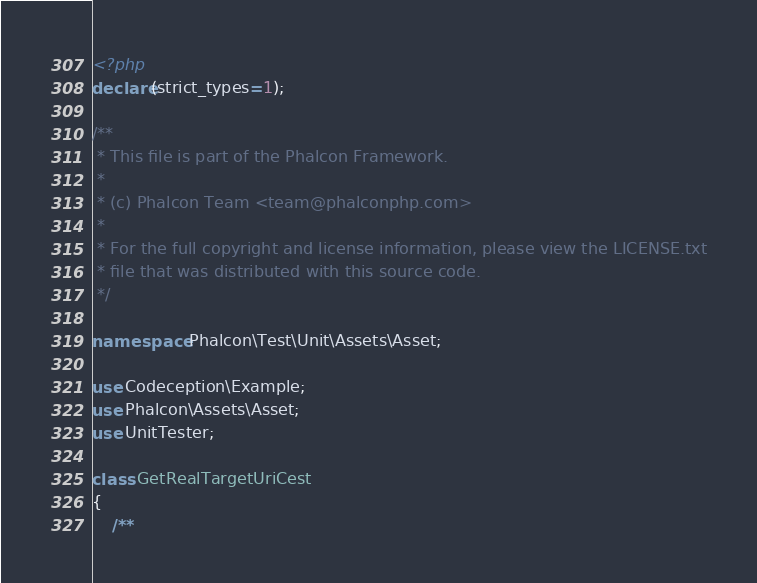Convert code to text. <code><loc_0><loc_0><loc_500><loc_500><_PHP_><?php
declare(strict_types=1);

/**
 * This file is part of the Phalcon Framework.
 *
 * (c) Phalcon Team <team@phalconphp.com>
 *
 * For the full copyright and license information, please view the LICENSE.txt
 * file that was distributed with this source code.
 */

namespace Phalcon\Test\Unit\Assets\Asset;

use Codeception\Example;
use Phalcon\Assets\Asset;
use UnitTester;

class GetRealTargetUriCest
{
    /**</code> 